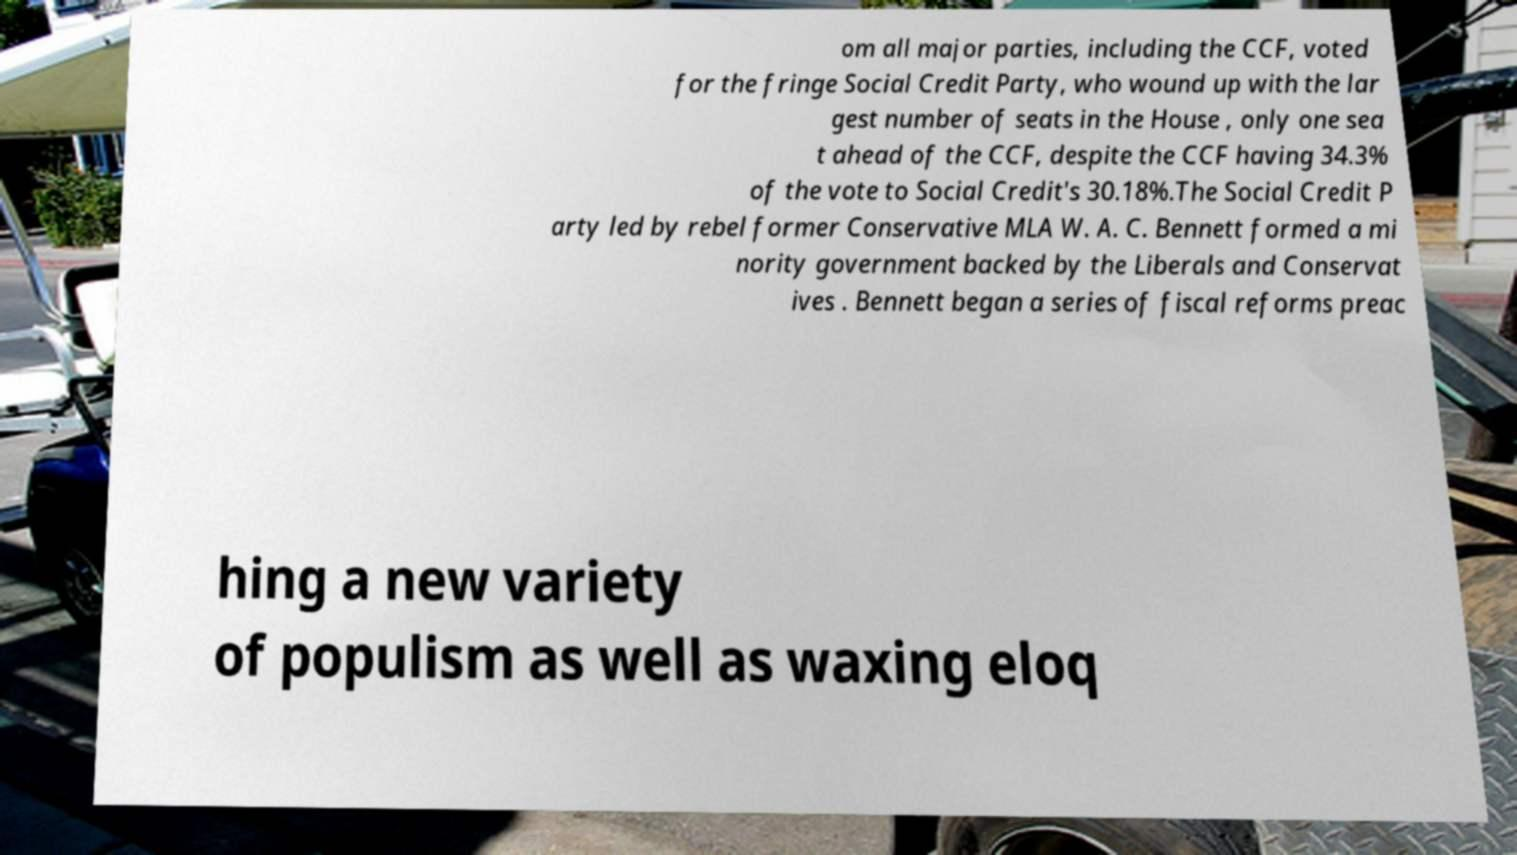Could you assist in decoding the text presented in this image and type it out clearly? om all major parties, including the CCF, voted for the fringe Social Credit Party, who wound up with the lar gest number of seats in the House , only one sea t ahead of the CCF, despite the CCF having 34.3% of the vote to Social Credit's 30.18%.The Social Credit P arty led by rebel former Conservative MLA W. A. C. Bennett formed a mi nority government backed by the Liberals and Conservat ives . Bennett began a series of fiscal reforms preac hing a new variety of populism as well as waxing eloq 